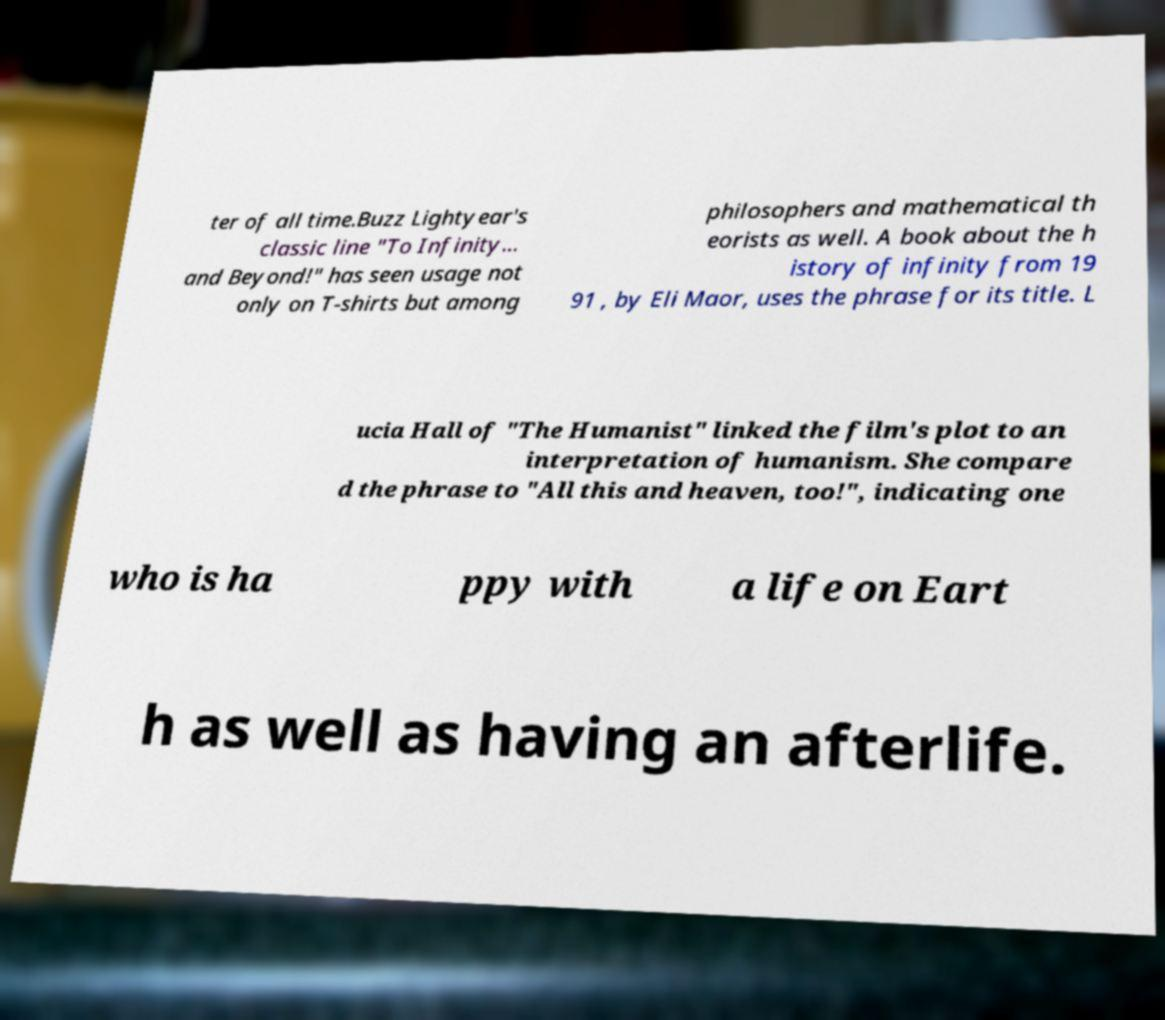Please identify and transcribe the text found in this image. ter of all time.Buzz Lightyear's classic line "To Infinity... and Beyond!" has seen usage not only on T-shirts but among philosophers and mathematical th eorists as well. A book about the h istory of infinity from 19 91 , by Eli Maor, uses the phrase for its title. L ucia Hall of "The Humanist" linked the film's plot to an interpretation of humanism. She compare d the phrase to "All this and heaven, too!", indicating one who is ha ppy with a life on Eart h as well as having an afterlife. 